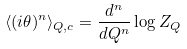<formula> <loc_0><loc_0><loc_500><loc_500>\langle ( i \theta ) ^ { n } \rangle _ { Q , c } = \frac { d ^ { n } } { d Q ^ { n } } \log Z _ { Q }</formula> 